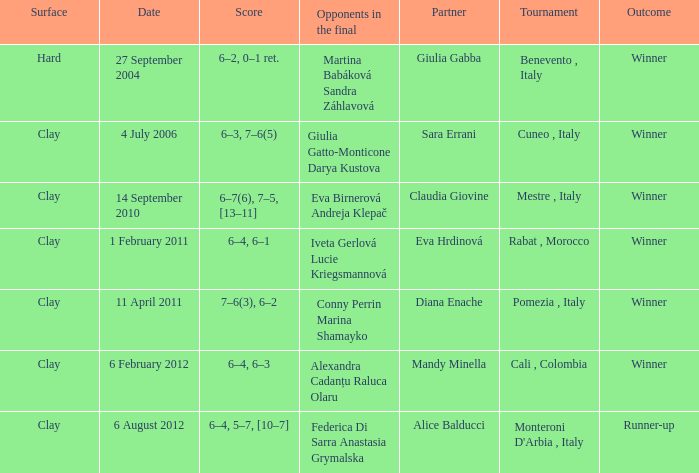Who participated on a tough surface? Giulia Gabba. 